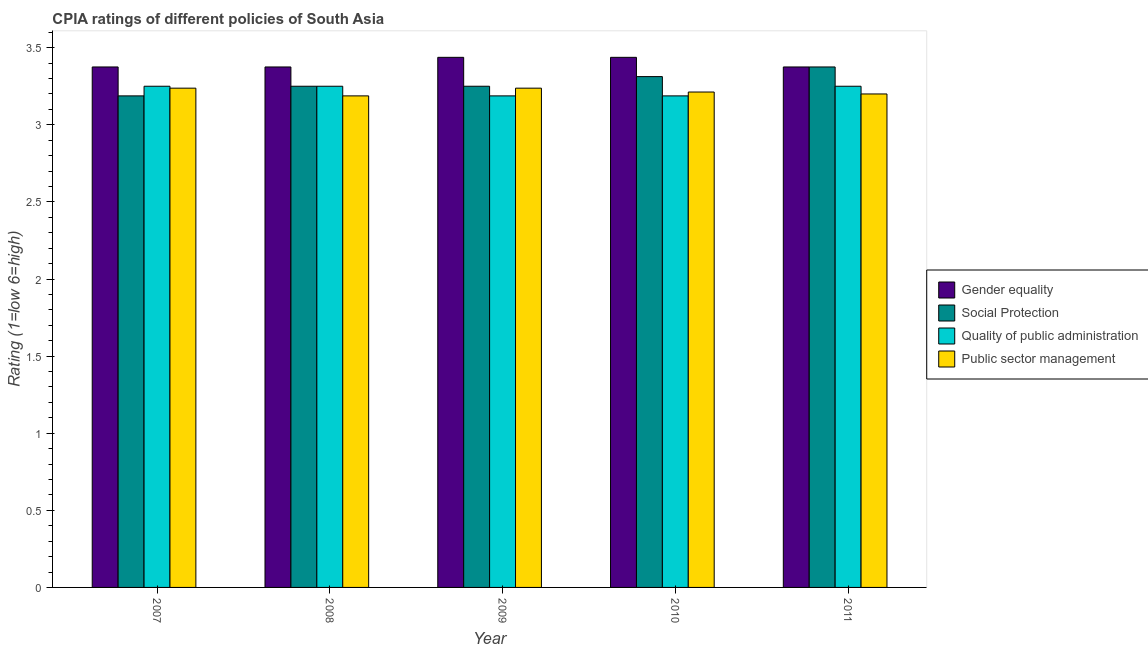How many groups of bars are there?
Ensure brevity in your answer.  5. Are the number of bars on each tick of the X-axis equal?
Your answer should be very brief. Yes. How many bars are there on the 1st tick from the right?
Give a very brief answer. 4. What is the label of the 4th group of bars from the left?
Provide a short and direct response. 2010. What is the cpia rating of public sector management in 2011?
Make the answer very short. 3.2. Across all years, what is the minimum cpia rating of quality of public administration?
Offer a very short reply. 3.19. What is the total cpia rating of public sector management in the graph?
Provide a short and direct response. 16.07. What is the difference between the cpia rating of gender equality in 2007 and that in 2010?
Your response must be concise. -0.06. What is the difference between the cpia rating of gender equality in 2010 and the cpia rating of social protection in 2011?
Provide a short and direct response. 0.06. What is the average cpia rating of gender equality per year?
Offer a terse response. 3.4. In how many years, is the cpia rating of gender equality greater than 3.4?
Provide a succinct answer. 2. What is the ratio of the cpia rating of social protection in 2009 to that in 2010?
Keep it short and to the point. 0.98. Is the cpia rating of public sector management in 2010 less than that in 2011?
Offer a terse response. No. What is the difference between the highest and the lowest cpia rating of social protection?
Your answer should be compact. 0.19. In how many years, is the cpia rating of public sector management greater than the average cpia rating of public sector management taken over all years?
Your answer should be compact. 2. Is it the case that in every year, the sum of the cpia rating of social protection and cpia rating of public sector management is greater than the sum of cpia rating of gender equality and cpia rating of quality of public administration?
Provide a short and direct response. No. What does the 4th bar from the left in 2010 represents?
Offer a terse response. Public sector management. What does the 4th bar from the right in 2008 represents?
Offer a terse response. Gender equality. Is it the case that in every year, the sum of the cpia rating of gender equality and cpia rating of social protection is greater than the cpia rating of quality of public administration?
Make the answer very short. Yes. Are all the bars in the graph horizontal?
Offer a terse response. No. Are the values on the major ticks of Y-axis written in scientific E-notation?
Your answer should be very brief. No. Does the graph contain any zero values?
Ensure brevity in your answer.  No. Does the graph contain grids?
Ensure brevity in your answer.  No. What is the title of the graph?
Keep it short and to the point. CPIA ratings of different policies of South Asia. Does "Arable land" appear as one of the legend labels in the graph?
Give a very brief answer. No. What is the label or title of the X-axis?
Your response must be concise. Year. What is the label or title of the Y-axis?
Make the answer very short. Rating (1=low 6=high). What is the Rating (1=low 6=high) in Gender equality in 2007?
Offer a very short reply. 3.38. What is the Rating (1=low 6=high) of Social Protection in 2007?
Keep it short and to the point. 3.19. What is the Rating (1=low 6=high) of Quality of public administration in 2007?
Offer a very short reply. 3.25. What is the Rating (1=low 6=high) in Public sector management in 2007?
Offer a terse response. 3.24. What is the Rating (1=low 6=high) of Gender equality in 2008?
Offer a very short reply. 3.38. What is the Rating (1=low 6=high) in Public sector management in 2008?
Provide a succinct answer. 3.19. What is the Rating (1=low 6=high) of Gender equality in 2009?
Your answer should be very brief. 3.44. What is the Rating (1=low 6=high) in Social Protection in 2009?
Provide a succinct answer. 3.25. What is the Rating (1=low 6=high) of Quality of public administration in 2009?
Make the answer very short. 3.19. What is the Rating (1=low 6=high) in Public sector management in 2009?
Provide a succinct answer. 3.24. What is the Rating (1=low 6=high) in Gender equality in 2010?
Offer a terse response. 3.44. What is the Rating (1=low 6=high) of Social Protection in 2010?
Offer a very short reply. 3.31. What is the Rating (1=low 6=high) in Quality of public administration in 2010?
Offer a very short reply. 3.19. What is the Rating (1=low 6=high) of Public sector management in 2010?
Offer a terse response. 3.21. What is the Rating (1=low 6=high) in Gender equality in 2011?
Keep it short and to the point. 3.38. What is the Rating (1=low 6=high) in Social Protection in 2011?
Provide a succinct answer. 3.38. What is the Rating (1=low 6=high) of Public sector management in 2011?
Your answer should be very brief. 3.2. Across all years, what is the maximum Rating (1=low 6=high) of Gender equality?
Give a very brief answer. 3.44. Across all years, what is the maximum Rating (1=low 6=high) in Social Protection?
Offer a very short reply. 3.38. Across all years, what is the maximum Rating (1=low 6=high) in Public sector management?
Offer a terse response. 3.24. Across all years, what is the minimum Rating (1=low 6=high) in Gender equality?
Your answer should be very brief. 3.38. Across all years, what is the minimum Rating (1=low 6=high) of Social Protection?
Your answer should be very brief. 3.19. Across all years, what is the minimum Rating (1=low 6=high) of Quality of public administration?
Offer a terse response. 3.19. Across all years, what is the minimum Rating (1=low 6=high) of Public sector management?
Provide a short and direct response. 3.19. What is the total Rating (1=low 6=high) of Social Protection in the graph?
Offer a terse response. 16.38. What is the total Rating (1=low 6=high) in Quality of public administration in the graph?
Your answer should be compact. 16.12. What is the total Rating (1=low 6=high) of Public sector management in the graph?
Offer a terse response. 16.07. What is the difference between the Rating (1=low 6=high) of Social Protection in 2007 and that in 2008?
Keep it short and to the point. -0.06. What is the difference between the Rating (1=low 6=high) of Public sector management in 2007 and that in 2008?
Provide a short and direct response. 0.05. What is the difference between the Rating (1=low 6=high) of Gender equality in 2007 and that in 2009?
Ensure brevity in your answer.  -0.06. What is the difference between the Rating (1=low 6=high) in Social Protection in 2007 and that in 2009?
Your answer should be compact. -0.06. What is the difference between the Rating (1=low 6=high) in Quality of public administration in 2007 and that in 2009?
Ensure brevity in your answer.  0.06. What is the difference between the Rating (1=low 6=high) in Public sector management in 2007 and that in 2009?
Keep it short and to the point. 0. What is the difference between the Rating (1=low 6=high) of Gender equality in 2007 and that in 2010?
Your response must be concise. -0.06. What is the difference between the Rating (1=low 6=high) in Social Protection in 2007 and that in 2010?
Make the answer very short. -0.12. What is the difference between the Rating (1=low 6=high) in Quality of public administration in 2007 and that in 2010?
Offer a very short reply. 0.06. What is the difference between the Rating (1=low 6=high) of Public sector management in 2007 and that in 2010?
Make the answer very short. 0.03. What is the difference between the Rating (1=low 6=high) in Gender equality in 2007 and that in 2011?
Offer a very short reply. 0. What is the difference between the Rating (1=low 6=high) of Social Protection in 2007 and that in 2011?
Your answer should be compact. -0.19. What is the difference between the Rating (1=low 6=high) of Public sector management in 2007 and that in 2011?
Your answer should be very brief. 0.04. What is the difference between the Rating (1=low 6=high) of Gender equality in 2008 and that in 2009?
Provide a succinct answer. -0.06. What is the difference between the Rating (1=low 6=high) in Quality of public administration in 2008 and that in 2009?
Your response must be concise. 0.06. What is the difference between the Rating (1=low 6=high) in Gender equality in 2008 and that in 2010?
Offer a terse response. -0.06. What is the difference between the Rating (1=low 6=high) in Social Protection in 2008 and that in 2010?
Keep it short and to the point. -0.06. What is the difference between the Rating (1=low 6=high) of Quality of public administration in 2008 and that in 2010?
Provide a short and direct response. 0.06. What is the difference between the Rating (1=low 6=high) of Public sector management in 2008 and that in 2010?
Offer a very short reply. -0.03. What is the difference between the Rating (1=low 6=high) of Social Protection in 2008 and that in 2011?
Give a very brief answer. -0.12. What is the difference between the Rating (1=low 6=high) in Quality of public administration in 2008 and that in 2011?
Make the answer very short. 0. What is the difference between the Rating (1=low 6=high) in Public sector management in 2008 and that in 2011?
Ensure brevity in your answer.  -0.01. What is the difference between the Rating (1=low 6=high) of Gender equality in 2009 and that in 2010?
Provide a succinct answer. 0. What is the difference between the Rating (1=low 6=high) in Social Protection in 2009 and that in 2010?
Provide a short and direct response. -0.06. What is the difference between the Rating (1=low 6=high) of Public sector management in 2009 and that in 2010?
Ensure brevity in your answer.  0.03. What is the difference between the Rating (1=low 6=high) in Gender equality in 2009 and that in 2011?
Keep it short and to the point. 0.06. What is the difference between the Rating (1=low 6=high) of Social Protection in 2009 and that in 2011?
Your response must be concise. -0.12. What is the difference between the Rating (1=low 6=high) of Quality of public administration in 2009 and that in 2011?
Give a very brief answer. -0.06. What is the difference between the Rating (1=low 6=high) of Public sector management in 2009 and that in 2011?
Make the answer very short. 0.04. What is the difference between the Rating (1=low 6=high) in Gender equality in 2010 and that in 2011?
Your answer should be very brief. 0.06. What is the difference between the Rating (1=low 6=high) of Social Protection in 2010 and that in 2011?
Keep it short and to the point. -0.06. What is the difference between the Rating (1=low 6=high) of Quality of public administration in 2010 and that in 2011?
Keep it short and to the point. -0.06. What is the difference between the Rating (1=low 6=high) of Public sector management in 2010 and that in 2011?
Your answer should be compact. 0.01. What is the difference between the Rating (1=low 6=high) of Gender equality in 2007 and the Rating (1=low 6=high) of Quality of public administration in 2008?
Provide a short and direct response. 0.12. What is the difference between the Rating (1=low 6=high) in Gender equality in 2007 and the Rating (1=low 6=high) in Public sector management in 2008?
Make the answer very short. 0.19. What is the difference between the Rating (1=low 6=high) in Social Protection in 2007 and the Rating (1=low 6=high) in Quality of public administration in 2008?
Provide a succinct answer. -0.06. What is the difference between the Rating (1=low 6=high) in Social Protection in 2007 and the Rating (1=low 6=high) in Public sector management in 2008?
Provide a short and direct response. 0. What is the difference between the Rating (1=low 6=high) of Quality of public administration in 2007 and the Rating (1=low 6=high) of Public sector management in 2008?
Provide a succinct answer. 0.06. What is the difference between the Rating (1=low 6=high) in Gender equality in 2007 and the Rating (1=low 6=high) in Quality of public administration in 2009?
Give a very brief answer. 0.19. What is the difference between the Rating (1=low 6=high) of Gender equality in 2007 and the Rating (1=low 6=high) of Public sector management in 2009?
Offer a terse response. 0.14. What is the difference between the Rating (1=low 6=high) of Quality of public administration in 2007 and the Rating (1=low 6=high) of Public sector management in 2009?
Keep it short and to the point. 0.01. What is the difference between the Rating (1=low 6=high) of Gender equality in 2007 and the Rating (1=low 6=high) of Social Protection in 2010?
Ensure brevity in your answer.  0.06. What is the difference between the Rating (1=low 6=high) of Gender equality in 2007 and the Rating (1=low 6=high) of Quality of public administration in 2010?
Your response must be concise. 0.19. What is the difference between the Rating (1=low 6=high) of Gender equality in 2007 and the Rating (1=low 6=high) of Public sector management in 2010?
Give a very brief answer. 0.16. What is the difference between the Rating (1=low 6=high) in Social Protection in 2007 and the Rating (1=low 6=high) in Quality of public administration in 2010?
Offer a very short reply. 0. What is the difference between the Rating (1=low 6=high) in Social Protection in 2007 and the Rating (1=low 6=high) in Public sector management in 2010?
Provide a short and direct response. -0.03. What is the difference between the Rating (1=low 6=high) in Quality of public administration in 2007 and the Rating (1=low 6=high) in Public sector management in 2010?
Provide a succinct answer. 0.04. What is the difference between the Rating (1=low 6=high) in Gender equality in 2007 and the Rating (1=low 6=high) in Public sector management in 2011?
Keep it short and to the point. 0.17. What is the difference between the Rating (1=low 6=high) of Social Protection in 2007 and the Rating (1=low 6=high) of Quality of public administration in 2011?
Your answer should be compact. -0.06. What is the difference between the Rating (1=low 6=high) in Social Protection in 2007 and the Rating (1=low 6=high) in Public sector management in 2011?
Your answer should be very brief. -0.01. What is the difference between the Rating (1=low 6=high) of Gender equality in 2008 and the Rating (1=low 6=high) of Quality of public administration in 2009?
Your response must be concise. 0.19. What is the difference between the Rating (1=low 6=high) of Gender equality in 2008 and the Rating (1=low 6=high) of Public sector management in 2009?
Your answer should be very brief. 0.14. What is the difference between the Rating (1=low 6=high) in Social Protection in 2008 and the Rating (1=low 6=high) in Quality of public administration in 2009?
Your answer should be compact. 0.06. What is the difference between the Rating (1=low 6=high) in Social Protection in 2008 and the Rating (1=low 6=high) in Public sector management in 2009?
Make the answer very short. 0.01. What is the difference between the Rating (1=low 6=high) in Quality of public administration in 2008 and the Rating (1=low 6=high) in Public sector management in 2009?
Provide a short and direct response. 0.01. What is the difference between the Rating (1=low 6=high) of Gender equality in 2008 and the Rating (1=low 6=high) of Social Protection in 2010?
Provide a short and direct response. 0.06. What is the difference between the Rating (1=low 6=high) in Gender equality in 2008 and the Rating (1=low 6=high) in Quality of public administration in 2010?
Provide a short and direct response. 0.19. What is the difference between the Rating (1=low 6=high) in Gender equality in 2008 and the Rating (1=low 6=high) in Public sector management in 2010?
Your response must be concise. 0.16. What is the difference between the Rating (1=low 6=high) in Social Protection in 2008 and the Rating (1=low 6=high) in Quality of public administration in 2010?
Offer a terse response. 0.06. What is the difference between the Rating (1=low 6=high) in Social Protection in 2008 and the Rating (1=low 6=high) in Public sector management in 2010?
Your response must be concise. 0.04. What is the difference between the Rating (1=low 6=high) of Quality of public administration in 2008 and the Rating (1=low 6=high) of Public sector management in 2010?
Provide a succinct answer. 0.04. What is the difference between the Rating (1=low 6=high) in Gender equality in 2008 and the Rating (1=low 6=high) in Public sector management in 2011?
Offer a very short reply. 0.17. What is the difference between the Rating (1=low 6=high) in Social Protection in 2008 and the Rating (1=low 6=high) in Quality of public administration in 2011?
Offer a very short reply. 0. What is the difference between the Rating (1=low 6=high) of Gender equality in 2009 and the Rating (1=low 6=high) of Public sector management in 2010?
Keep it short and to the point. 0.23. What is the difference between the Rating (1=low 6=high) of Social Protection in 2009 and the Rating (1=low 6=high) of Quality of public administration in 2010?
Keep it short and to the point. 0.06. What is the difference between the Rating (1=low 6=high) of Social Protection in 2009 and the Rating (1=low 6=high) of Public sector management in 2010?
Keep it short and to the point. 0.04. What is the difference between the Rating (1=low 6=high) in Quality of public administration in 2009 and the Rating (1=low 6=high) in Public sector management in 2010?
Your answer should be very brief. -0.03. What is the difference between the Rating (1=low 6=high) of Gender equality in 2009 and the Rating (1=low 6=high) of Social Protection in 2011?
Offer a terse response. 0.06. What is the difference between the Rating (1=low 6=high) of Gender equality in 2009 and the Rating (1=low 6=high) of Quality of public administration in 2011?
Offer a very short reply. 0.19. What is the difference between the Rating (1=low 6=high) in Gender equality in 2009 and the Rating (1=low 6=high) in Public sector management in 2011?
Your answer should be very brief. 0.24. What is the difference between the Rating (1=low 6=high) in Social Protection in 2009 and the Rating (1=low 6=high) in Quality of public administration in 2011?
Your answer should be very brief. 0. What is the difference between the Rating (1=low 6=high) in Social Protection in 2009 and the Rating (1=low 6=high) in Public sector management in 2011?
Provide a succinct answer. 0.05. What is the difference between the Rating (1=low 6=high) in Quality of public administration in 2009 and the Rating (1=low 6=high) in Public sector management in 2011?
Ensure brevity in your answer.  -0.01. What is the difference between the Rating (1=low 6=high) of Gender equality in 2010 and the Rating (1=low 6=high) of Social Protection in 2011?
Your response must be concise. 0.06. What is the difference between the Rating (1=low 6=high) of Gender equality in 2010 and the Rating (1=low 6=high) of Quality of public administration in 2011?
Keep it short and to the point. 0.19. What is the difference between the Rating (1=low 6=high) of Gender equality in 2010 and the Rating (1=low 6=high) of Public sector management in 2011?
Ensure brevity in your answer.  0.24. What is the difference between the Rating (1=low 6=high) in Social Protection in 2010 and the Rating (1=low 6=high) in Quality of public administration in 2011?
Your answer should be very brief. 0.06. What is the difference between the Rating (1=low 6=high) of Social Protection in 2010 and the Rating (1=low 6=high) of Public sector management in 2011?
Offer a terse response. 0.11. What is the difference between the Rating (1=low 6=high) of Quality of public administration in 2010 and the Rating (1=low 6=high) of Public sector management in 2011?
Offer a terse response. -0.01. What is the average Rating (1=low 6=high) in Gender equality per year?
Keep it short and to the point. 3.4. What is the average Rating (1=low 6=high) of Social Protection per year?
Provide a short and direct response. 3.27. What is the average Rating (1=low 6=high) of Quality of public administration per year?
Your answer should be compact. 3.23. What is the average Rating (1=low 6=high) in Public sector management per year?
Make the answer very short. 3.21. In the year 2007, what is the difference between the Rating (1=low 6=high) of Gender equality and Rating (1=low 6=high) of Social Protection?
Make the answer very short. 0.19. In the year 2007, what is the difference between the Rating (1=low 6=high) of Gender equality and Rating (1=low 6=high) of Quality of public administration?
Offer a terse response. 0.12. In the year 2007, what is the difference between the Rating (1=low 6=high) in Gender equality and Rating (1=low 6=high) in Public sector management?
Ensure brevity in your answer.  0.14. In the year 2007, what is the difference between the Rating (1=low 6=high) of Social Protection and Rating (1=low 6=high) of Quality of public administration?
Give a very brief answer. -0.06. In the year 2007, what is the difference between the Rating (1=low 6=high) in Quality of public administration and Rating (1=low 6=high) in Public sector management?
Ensure brevity in your answer.  0.01. In the year 2008, what is the difference between the Rating (1=low 6=high) in Gender equality and Rating (1=low 6=high) in Social Protection?
Give a very brief answer. 0.12. In the year 2008, what is the difference between the Rating (1=low 6=high) of Gender equality and Rating (1=low 6=high) of Quality of public administration?
Give a very brief answer. 0.12. In the year 2008, what is the difference between the Rating (1=low 6=high) in Gender equality and Rating (1=low 6=high) in Public sector management?
Your answer should be compact. 0.19. In the year 2008, what is the difference between the Rating (1=low 6=high) in Social Protection and Rating (1=low 6=high) in Public sector management?
Offer a very short reply. 0.06. In the year 2008, what is the difference between the Rating (1=low 6=high) in Quality of public administration and Rating (1=low 6=high) in Public sector management?
Your answer should be compact. 0.06. In the year 2009, what is the difference between the Rating (1=low 6=high) of Gender equality and Rating (1=low 6=high) of Social Protection?
Ensure brevity in your answer.  0.19. In the year 2009, what is the difference between the Rating (1=low 6=high) in Gender equality and Rating (1=low 6=high) in Public sector management?
Offer a terse response. 0.2. In the year 2009, what is the difference between the Rating (1=low 6=high) of Social Protection and Rating (1=low 6=high) of Quality of public administration?
Your response must be concise. 0.06. In the year 2009, what is the difference between the Rating (1=low 6=high) in Social Protection and Rating (1=low 6=high) in Public sector management?
Offer a very short reply. 0.01. In the year 2010, what is the difference between the Rating (1=low 6=high) in Gender equality and Rating (1=low 6=high) in Public sector management?
Offer a terse response. 0.23. In the year 2010, what is the difference between the Rating (1=low 6=high) in Social Protection and Rating (1=low 6=high) in Public sector management?
Give a very brief answer. 0.1. In the year 2010, what is the difference between the Rating (1=low 6=high) in Quality of public administration and Rating (1=low 6=high) in Public sector management?
Your answer should be very brief. -0.03. In the year 2011, what is the difference between the Rating (1=low 6=high) in Gender equality and Rating (1=low 6=high) in Quality of public administration?
Keep it short and to the point. 0.12. In the year 2011, what is the difference between the Rating (1=low 6=high) in Gender equality and Rating (1=low 6=high) in Public sector management?
Provide a succinct answer. 0.17. In the year 2011, what is the difference between the Rating (1=low 6=high) in Social Protection and Rating (1=low 6=high) in Quality of public administration?
Your response must be concise. 0.12. In the year 2011, what is the difference between the Rating (1=low 6=high) of Social Protection and Rating (1=low 6=high) of Public sector management?
Your answer should be compact. 0.17. In the year 2011, what is the difference between the Rating (1=low 6=high) of Quality of public administration and Rating (1=low 6=high) of Public sector management?
Your answer should be very brief. 0.05. What is the ratio of the Rating (1=low 6=high) of Social Protection in 2007 to that in 2008?
Give a very brief answer. 0.98. What is the ratio of the Rating (1=low 6=high) of Quality of public administration in 2007 to that in 2008?
Provide a short and direct response. 1. What is the ratio of the Rating (1=low 6=high) of Public sector management in 2007 to that in 2008?
Provide a short and direct response. 1.02. What is the ratio of the Rating (1=low 6=high) in Gender equality in 2007 to that in 2009?
Your answer should be very brief. 0.98. What is the ratio of the Rating (1=low 6=high) of Social Protection in 2007 to that in 2009?
Provide a short and direct response. 0.98. What is the ratio of the Rating (1=low 6=high) in Quality of public administration in 2007 to that in 2009?
Give a very brief answer. 1.02. What is the ratio of the Rating (1=low 6=high) in Gender equality in 2007 to that in 2010?
Provide a succinct answer. 0.98. What is the ratio of the Rating (1=low 6=high) in Social Protection in 2007 to that in 2010?
Keep it short and to the point. 0.96. What is the ratio of the Rating (1=low 6=high) in Quality of public administration in 2007 to that in 2010?
Give a very brief answer. 1.02. What is the ratio of the Rating (1=low 6=high) in Gender equality in 2007 to that in 2011?
Provide a short and direct response. 1. What is the ratio of the Rating (1=low 6=high) of Quality of public administration in 2007 to that in 2011?
Give a very brief answer. 1. What is the ratio of the Rating (1=low 6=high) in Public sector management in 2007 to that in 2011?
Your answer should be very brief. 1.01. What is the ratio of the Rating (1=low 6=high) in Gender equality in 2008 to that in 2009?
Provide a succinct answer. 0.98. What is the ratio of the Rating (1=low 6=high) of Quality of public administration in 2008 to that in 2009?
Keep it short and to the point. 1.02. What is the ratio of the Rating (1=low 6=high) of Public sector management in 2008 to that in 2009?
Provide a succinct answer. 0.98. What is the ratio of the Rating (1=low 6=high) in Gender equality in 2008 to that in 2010?
Give a very brief answer. 0.98. What is the ratio of the Rating (1=low 6=high) of Social Protection in 2008 to that in 2010?
Make the answer very short. 0.98. What is the ratio of the Rating (1=low 6=high) of Quality of public administration in 2008 to that in 2010?
Your answer should be very brief. 1.02. What is the ratio of the Rating (1=low 6=high) of Gender equality in 2008 to that in 2011?
Ensure brevity in your answer.  1. What is the ratio of the Rating (1=low 6=high) of Public sector management in 2008 to that in 2011?
Provide a short and direct response. 1. What is the ratio of the Rating (1=low 6=high) in Gender equality in 2009 to that in 2010?
Keep it short and to the point. 1. What is the ratio of the Rating (1=low 6=high) in Social Protection in 2009 to that in 2010?
Offer a terse response. 0.98. What is the ratio of the Rating (1=low 6=high) in Quality of public administration in 2009 to that in 2010?
Offer a very short reply. 1. What is the ratio of the Rating (1=low 6=high) of Gender equality in 2009 to that in 2011?
Your answer should be very brief. 1.02. What is the ratio of the Rating (1=low 6=high) of Social Protection in 2009 to that in 2011?
Your response must be concise. 0.96. What is the ratio of the Rating (1=low 6=high) of Quality of public administration in 2009 to that in 2011?
Your answer should be compact. 0.98. What is the ratio of the Rating (1=low 6=high) of Public sector management in 2009 to that in 2011?
Your answer should be very brief. 1.01. What is the ratio of the Rating (1=low 6=high) of Gender equality in 2010 to that in 2011?
Keep it short and to the point. 1.02. What is the ratio of the Rating (1=low 6=high) in Social Protection in 2010 to that in 2011?
Your response must be concise. 0.98. What is the ratio of the Rating (1=low 6=high) of Quality of public administration in 2010 to that in 2011?
Ensure brevity in your answer.  0.98. What is the ratio of the Rating (1=low 6=high) of Public sector management in 2010 to that in 2011?
Make the answer very short. 1. What is the difference between the highest and the second highest Rating (1=low 6=high) of Gender equality?
Ensure brevity in your answer.  0. What is the difference between the highest and the second highest Rating (1=low 6=high) of Social Protection?
Ensure brevity in your answer.  0.06. What is the difference between the highest and the second highest Rating (1=low 6=high) in Quality of public administration?
Offer a very short reply. 0. What is the difference between the highest and the lowest Rating (1=low 6=high) in Gender equality?
Provide a short and direct response. 0.06. What is the difference between the highest and the lowest Rating (1=low 6=high) of Social Protection?
Offer a terse response. 0.19. What is the difference between the highest and the lowest Rating (1=low 6=high) of Quality of public administration?
Provide a succinct answer. 0.06. What is the difference between the highest and the lowest Rating (1=low 6=high) of Public sector management?
Give a very brief answer. 0.05. 